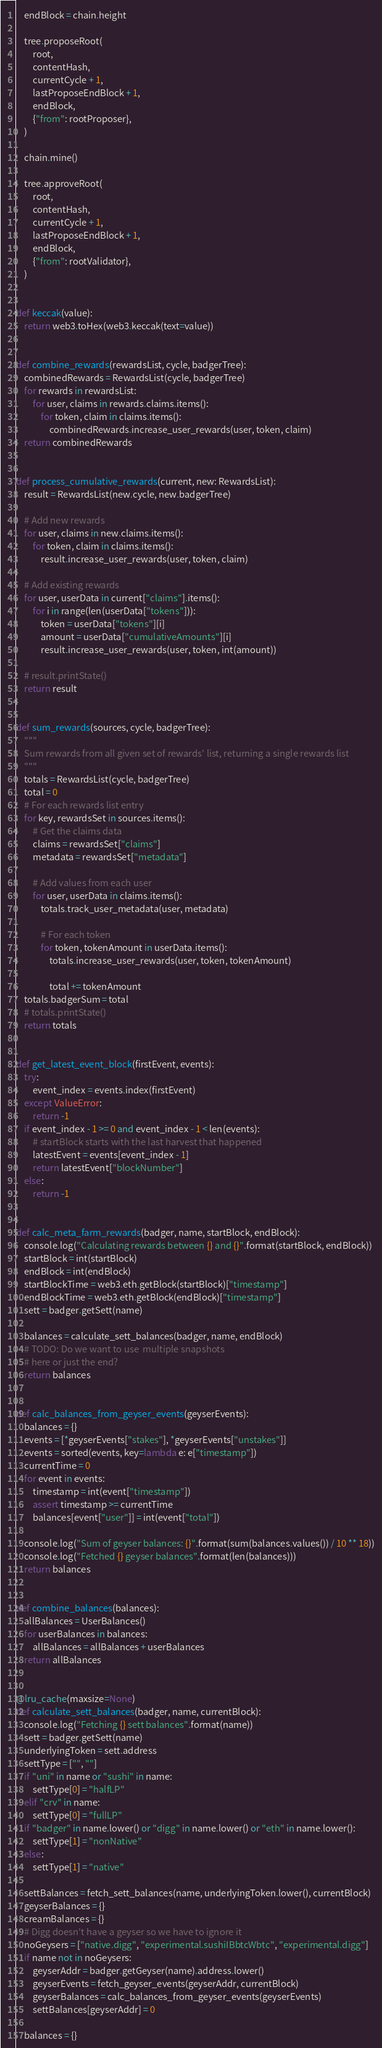Convert code to text. <code><loc_0><loc_0><loc_500><loc_500><_Python_>
    endBlock = chain.height

    tree.proposeRoot(
        root,
        contentHash,
        currentCycle + 1,
        lastProposeEndBlock + 1,
        endBlock,
        {"from": rootProposer},
    )

    chain.mine()

    tree.approveRoot(
        root,
        contentHash,
        currentCycle + 1,
        lastProposeEndBlock + 1,
        endBlock,
        {"from": rootValidator},
    )


def keccak(value):
    return web3.toHex(web3.keccak(text=value))


def combine_rewards(rewardsList, cycle, badgerTree):
    combinedRewards = RewardsList(cycle, badgerTree)
    for rewards in rewardsList:
        for user, claims in rewards.claims.items():
            for token, claim in claims.items():
                combinedRewards.increase_user_rewards(user, token, claim)
    return combinedRewards


def process_cumulative_rewards(current, new: RewardsList):
    result = RewardsList(new.cycle, new.badgerTree)

    # Add new rewards
    for user, claims in new.claims.items():
        for token, claim in claims.items():
            result.increase_user_rewards(user, token, claim)

    # Add existing rewards
    for user, userData in current["claims"].items():
        for i in range(len(userData["tokens"])):
            token = userData["tokens"][i]
            amount = userData["cumulativeAmounts"][i]
            result.increase_user_rewards(user, token, int(amount))

    # result.printState()
    return result


def sum_rewards(sources, cycle, badgerTree):
    """
    Sum rewards from all given set of rewards' list, returning a single rewards list
    """
    totals = RewardsList(cycle, badgerTree)
    total = 0
    # For each rewards list entry
    for key, rewardsSet in sources.items():
        # Get the claims data
        claims = rewardsSet["claims"]
        metadata = rewardsSet["metadata"]

        # Add values from each user
        for user, userData in claims.items():
            totals.track_user_metadata(user, metadata)

            # For each token
            for token, tokenAmount in userData.items():
                totals.increase_user_rewards(user, token, tokenAmount)

                total += tokenAmount
    totals.badgerSum = total
    # totals.printState()
    return totals


def get_latest_event_block(firstEvent, events):
    try:
        event_index = events.index(firstEvent)
    except ValueError:
        return -1
    if event_index - 1 >= 0 and event_index - 1 < len(events):
        # startBlock starts with the last harvest that happened
        latestEvent = events[event_index - 1]
        return latestEvent["blockNumber"]
    else:
        return -1


def calc_meta_farm_rewards(badger, name, startBlock, endBlock):
    console.log("Calculating rewards between {} and {}".format(startBlock, endBlock))
    startBlock = int(startBlock)
    endBlock = int(endBlock)
    startBlockTime = web3.eth.getBlock(startBlock)["timestamp"]
    endBlockTime = web3.eth.getBlock(endBlock)["timestamp"]
    sett = badger.getSett(name)

    balances = calculate_sett_balances(badger, name, endBlock)
    # TODO: Do we want to use  multiple snapshots
    # here or just the end?
    return balances


def calc_balances_from_geyser_events(geyserEvents):
    balances = {}
    events = [*geyserEvents["stakes"], *geyserEvents["unstakes"]]
    events = sorted(events, key=lambda e: e["timestamp"])
    currentTime = 0
    for event in events:
        timestamp = int(event["timestamp"])
        assert timestamp >= currentTime
        balances[event["user"]] = int(event["total"])

    console.log("Sum of geyser balances: {}".format(sum(balances.values()) / 10 ** 18))
    console.log("Fetched {} geyser balances".format(len(balances)))
    return balances


def combine_balances(balances):
    allBalances = UserBalances()
    for userBalances in balances:
        allBalances = allBalances + userBalances
    return allBalances


@lru_cache(maxsize=None)
def calculate_sett_balances(badger, name, currentBlock):
    console.log("Fetching {} sett balances".format(name))
    sett = badger.getSett(name)
    underlyingToken = sett.address
    settType = ["", ""]
    if "uni" in name or "sushi" in name:
        settType[0] = "halfLP"
    elif "crv" in name:
        settType[0] = "fullLP"
    if "badger" in name.lower() or "digg" in name.lower() or "eth" in name.lower():
        settType[1] = "nonNative"
    else:
        settType[1] = "native"

    settBalances = fetch_sett_balances(name, underlyingToken.lower(), currentBlock)
    geyserBalances = {}
    creamBalances = {}
    # Digg doesn't have a geyser so we have to ignore it
    noGeysers = ["native.digg", "experimental.sushiIBbtcWbtc", "experimental.digg"]
    if name not in noGeysers:
        geyserAddr = badger.getGeyser(name).address.lower()
        geyserEvents = fetch_geyser_events(geyserAddr, currentBlock)
        geyserBalances = calc_balances_from_geyser_events(geyserEvents)
        settBalances[geyserAddr] = 0

    balances = {}</code> 